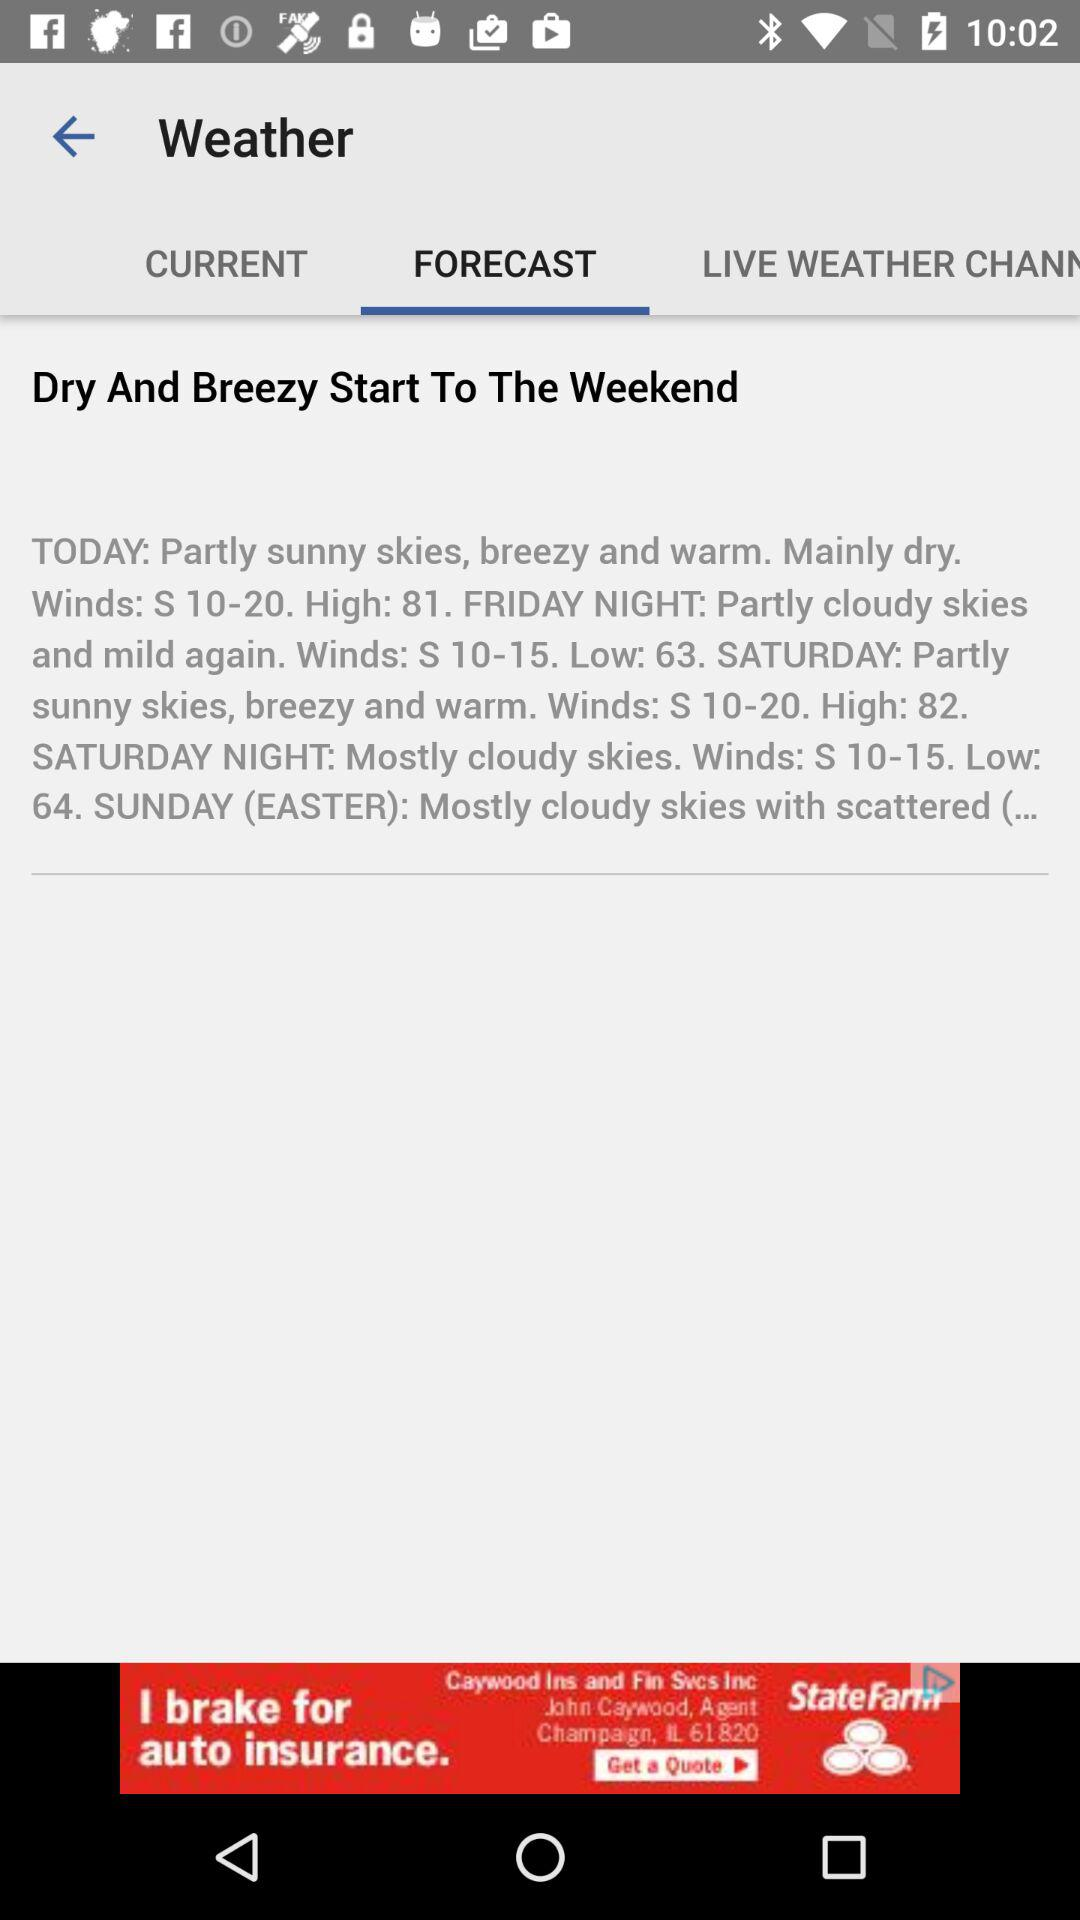How is the weather on Friday night? The weather is partly cloudy skies and mild again. 